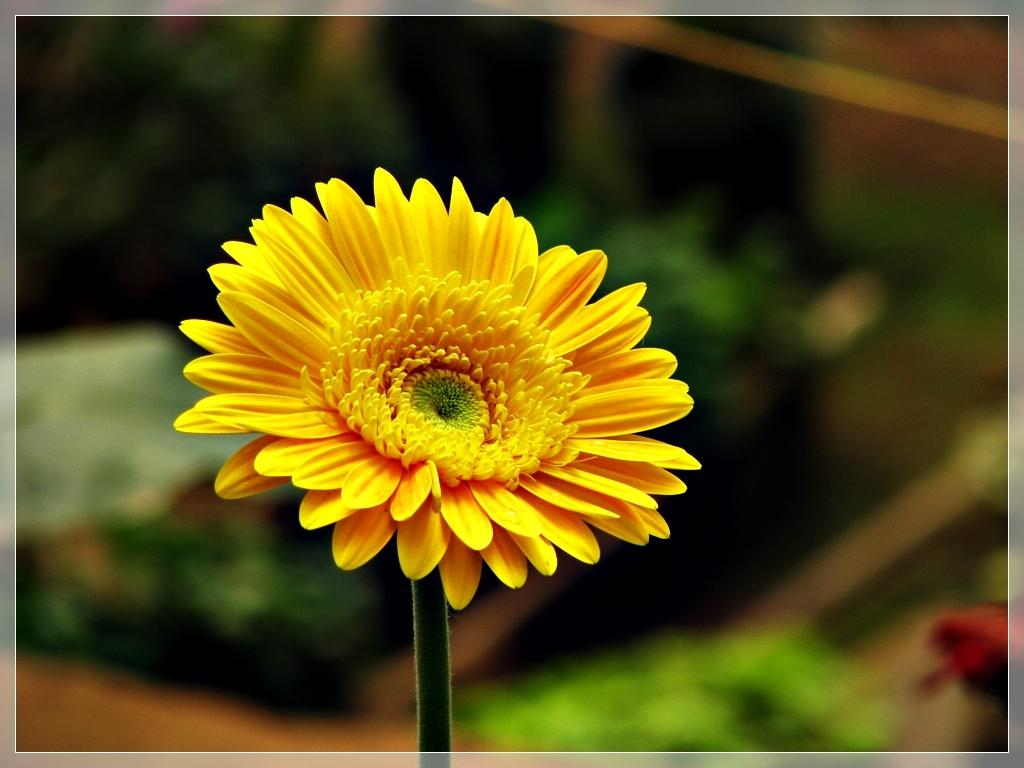What type of plant is the main subject of the image? There is a sunflower in the image. How is the sunflower attached to the stem? The sunflower is on a stem. What can be seen in the background of the image? There are plants in the background of the image. Can you describe the appearance of the background? The background is blurry. Is there any framing or decoration around the image? Yes, there is a border around the image. Can you tell me how many bears are visible in the image? There are no bears present in the image; it features a sunflower on a stem with a blurry background and a border. What type of mask is the sunflower wearing in the image? There is no mask present in the image; the sunflower is simply on a stem with a blurry background and a border. 